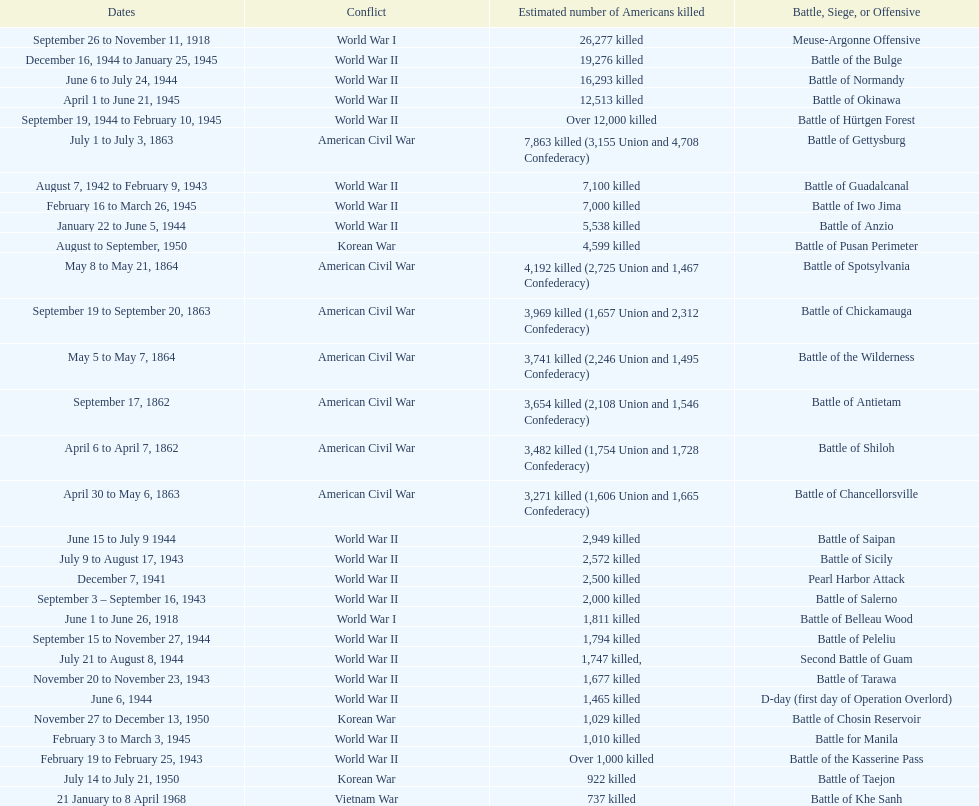How many battles resulted between 3,000 and 4,200 estimated americans killed? 6. 